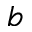<formula> <loc_0><loc_0><loc_500><loc_500>b</formula> 